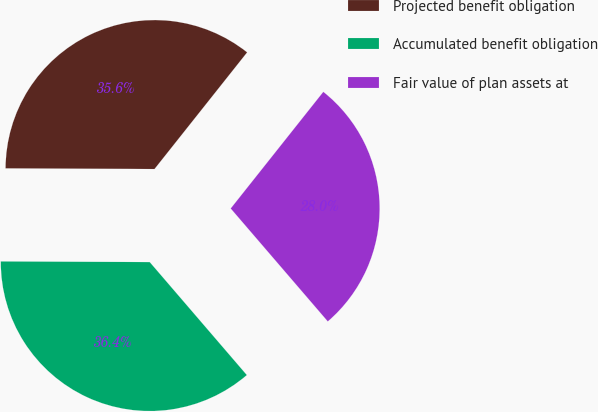Convert chart. <chart><loc_0><loc_0><loc_500><loc_500><pie_chart><fcel>Projected benefit obligation<fcel>Accumulated benefit obligation<fcel>Fair value of plan assets at<nl><fcel>35.61%<fcel>36.37%<fcel>28.02%<nl></chart> 